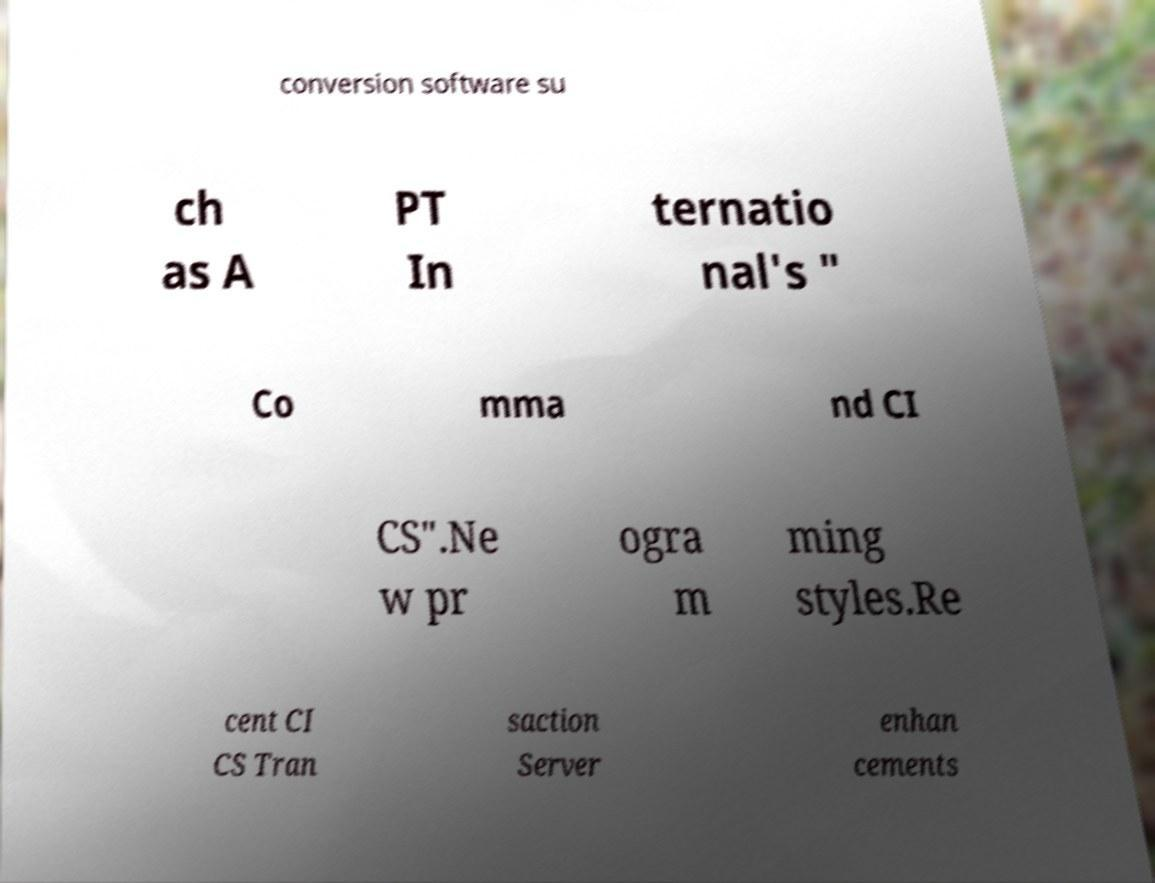For documentation purposes, I need the text within this image transcribed. Could you provide that? conversion software su ch as A PT In ternatio nal's " Co mma nd CI CS".Ne w pr ogra m ming styles.Re cent CI CS Tran saction Server enhan cements 